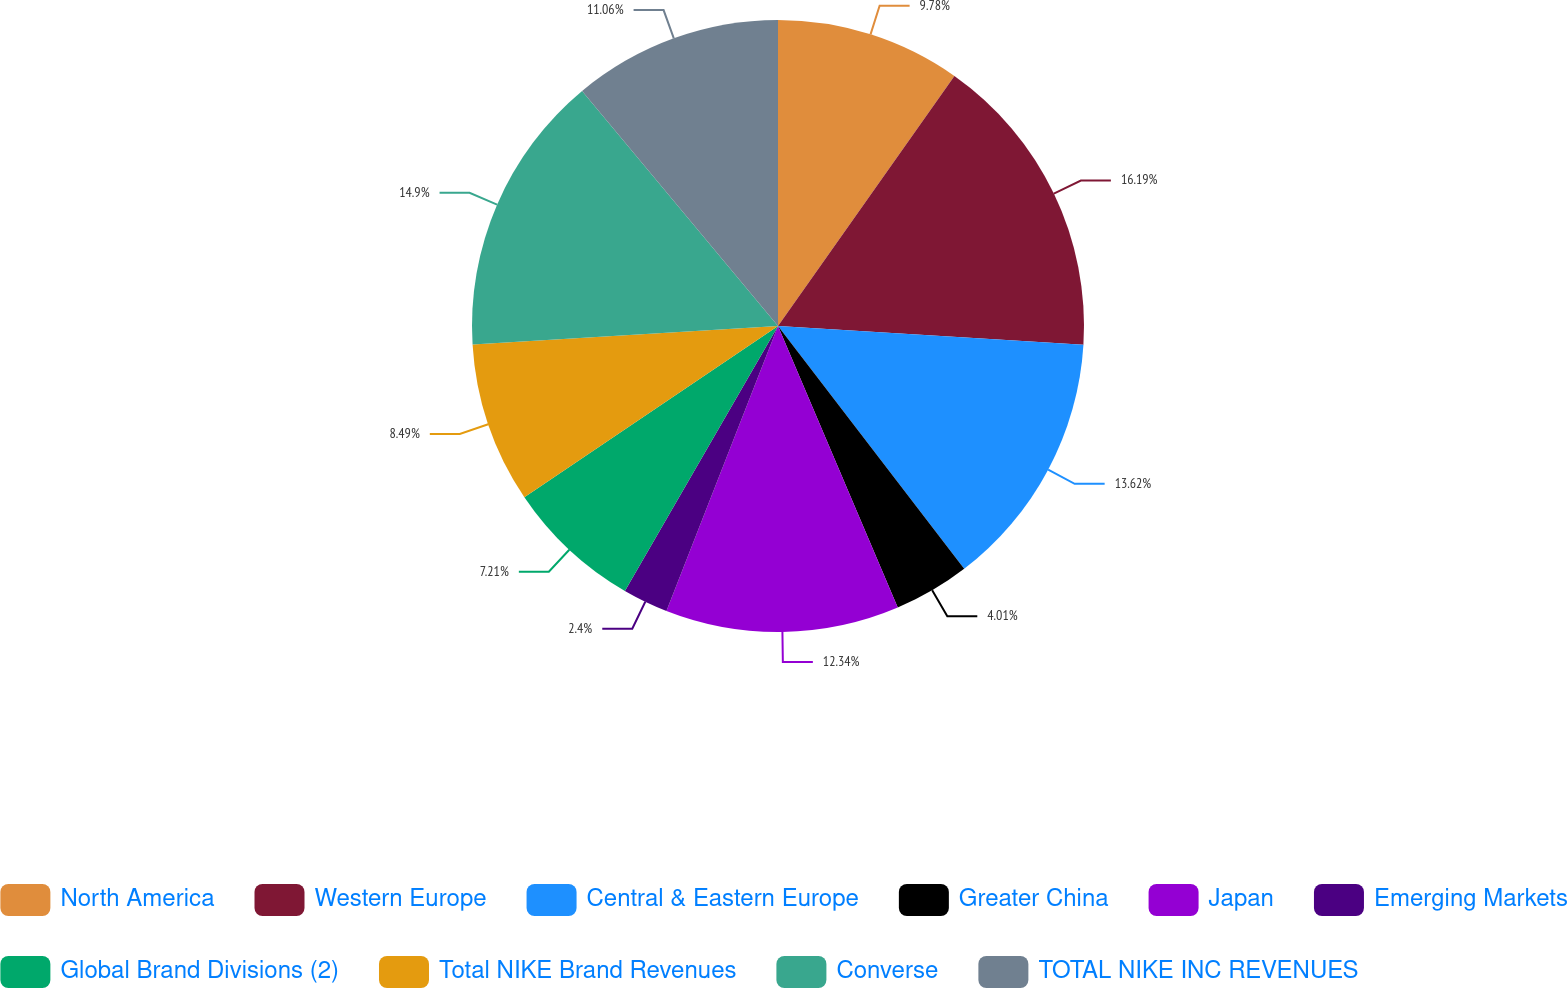<chart> <loc_0><loc_0><loc_500><loc_500><pie_chart><fcel>North America<fcel>Western Europe<fcel>Central & Eastern Europe<fcel>Greater China<fcel>Japan<fcel>Emerging Markets<fcel>Global Brand Divisions (2)<fcel>Total NIKE Brand Revenues<fcel>Converse<fcel>TOTAL NIKE INC REVENUES<nl><fcel>9.78%<fcel>16.19%<fcel>13.62%<fcel>4.01%<fcel>12.34%<fcel>2.4%<fcel>7.21%<fcel>8.49%<fcel>14.9%<fcel>11.06%<nl></chart> 